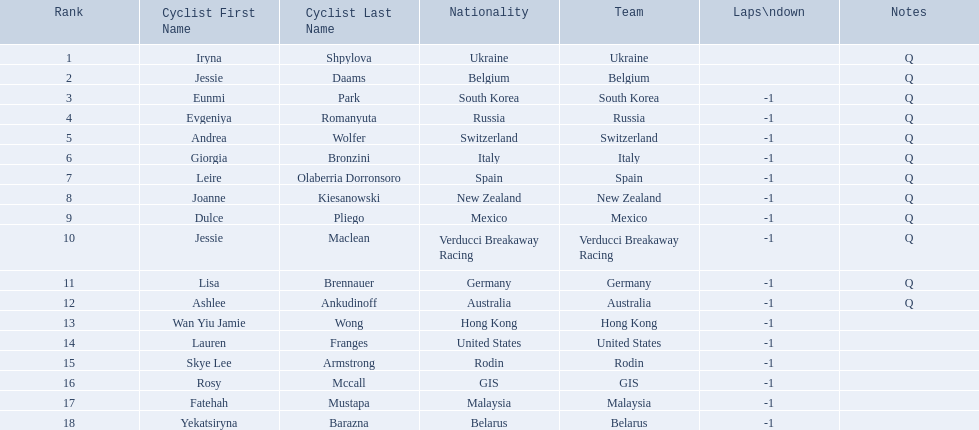Who competed in the race? Iryna Shpylova, Jessie Daams, Eunmi Park, Evgeniya Romanyuta, Andrea Wolfer, Giorgia Bronzini, Leire Olaberria Dorronsoro, Joanne Kiesanowski, Dulce Pliego, Jessie Maclean, Lisa Brennauer, Ashlee Ankudinoff, Wan Yiu Jamie Wong, Lauren Franges, Skye Lee Armstrong, Rosy Mccall, Fatehah Mustapa, Yekatsiryna Barazna. Who ranked highest in the race? Iryna Shpylova. 